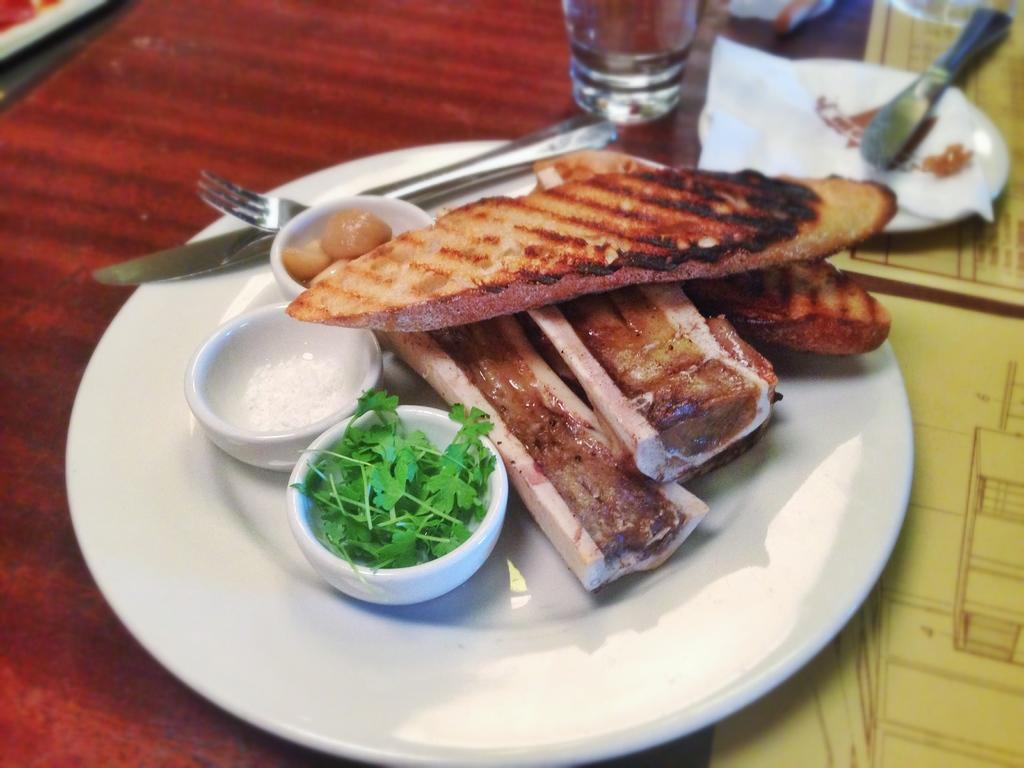What type of utensils can be seen on the table in the image? There are forks, spoons, and glasses on the table in the image. What else is present on the table besides utensils? There are plates, tissue papers, bowls, and food on the table. How many slaves are visible in the image? There are no slaves present in the image. What type of roll can be seen on the table in the image? There is no roll present on the table in the image. 